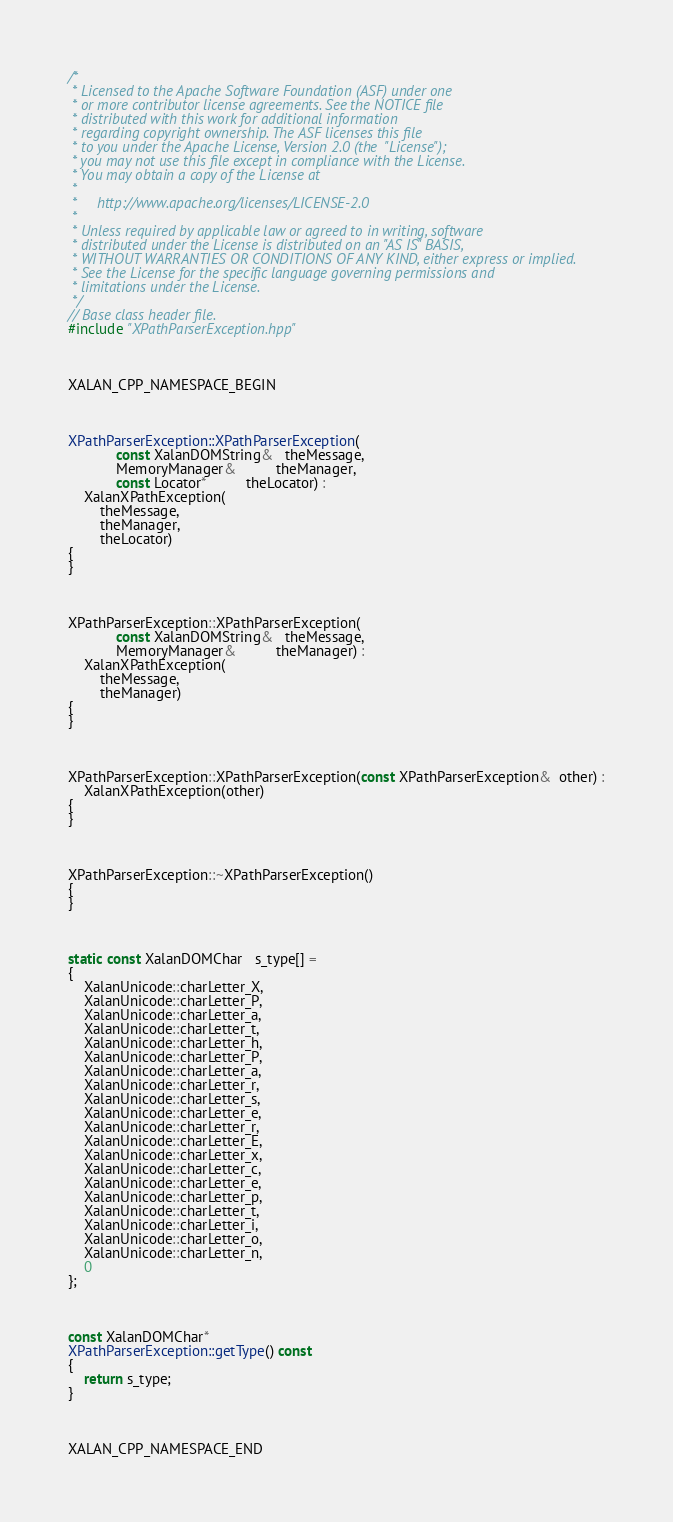Convert code to text. <code><loc_0><loc_0><loc_500><loc_500><_C++_>/*
 * Licensed to the Apache Software Foundation (ASF) under one
 * or more contributor license agreements. See the NOTICE file
 * distributed with this work for additional information
 * regarding copyright ownership. The ASF licenses this file
 * to you under the Apache License, Version 2.0 (the  "License");
 * you may not use this file except in compliance with the License.
 * You may obtain a copy of the License at
 *
 *     http://www.apache.org/licenses/LICENSE-2.0
 *
 * Unless required by applicable law or agreed to in writing, software
 * distributed under the License is distributed on an "AS IS" BASIS,
 * WITHOUT WARRANTIES OR CONDITIONS OF ANY KIND, either express or implied.
 * See the License for the specific language governing permissions and
 * limitations under the License.
 */
// Base class header file.
#include "XPathParserException.hpp"



XALAN_CPP_NAMESPACE_BEGIN



XPathParserException::XPathParserException(
            const XalanDOMString&   theMessage,
            MemoryManager&          theManager,
            const Locator*          theLocator) :
    XalanXPathException(
        theMessage,
        theManager,
        theLocator)
{
}



XPathParserException::XPathParserException(
            const XalanDOMString&   theMessage,
            MemoryManager&          theManager) :
    XalanXPathException(
        theMessage,
        theManager)
{
}



XPathParserException::XPathParserException(const XPathParserException&  other) :
    XalanXPathException(other)
{
}



XPathParserException::~XPathParserException()
{
}



static const XalanDOMChar   s_type[] = 
{   
    XalanUnicode::charLetter_X,
    XalanUnicode::charLetter_P,
    XalanUnicode::charLetter_a,
    XalanUnicode::charLetter_t,
    XalanUnicode::charLetter_h,
    XalanUnicode::charLetter_P,
    XalanUnicode::charLetter_a,
    XalanUnicode::charLetter_r,
    XalanUnicode::charLetter_s,
    XalanUnicode::charLetter_e,
    XalanUnicode::charLetter_r,
    XalanUnicode::charLetter_E,
    XalanUnicode::charLetter_x,
    XalanUnicode::charLetter_c,
    XalanUnicode::charLetter_e,
    XalanUnicode::charLetter_p,
    XalanUnicode::charLetter_t,
    XalanUnicode::charLetter_i,
    XalanUnicode::charLetter_o,
    XalanUnicode::charLetter_n,
    0
};



const XalanDOMChar*
XPathParserException::getType() const
{
    return s_type;
}



XALAN_CPP_NAMESPACE_END
</code> 